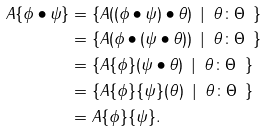Convert formula to latex. <formula><loc_0><loc_0><loc_500><loc_500>A \{ \phi \bullet \psi \} & = \{ A ( ( \phi \bullet \psi ) \bullet \theta ) \ \, | \ \, \theta \colon \Theta \ \, \} \\ & = \{ A ( \phi \bullet ( \psi \bullet \theta ) ) \ \, | \ \, \theta \colon \Theta \ \, \} \\ & = \{ A \{ \phi \} ( \psi \bullet \theta ) \ \, | \ \, \theta \colon \Theta \ \, \} \\ & = \{ A \{ \phi \} \{ \psi \} ( \theta ) \ \, | \ \, \theta \colon \Theta \ \, \} \\ & = A \{ \phi \} \{ \psi \} .</formula> 